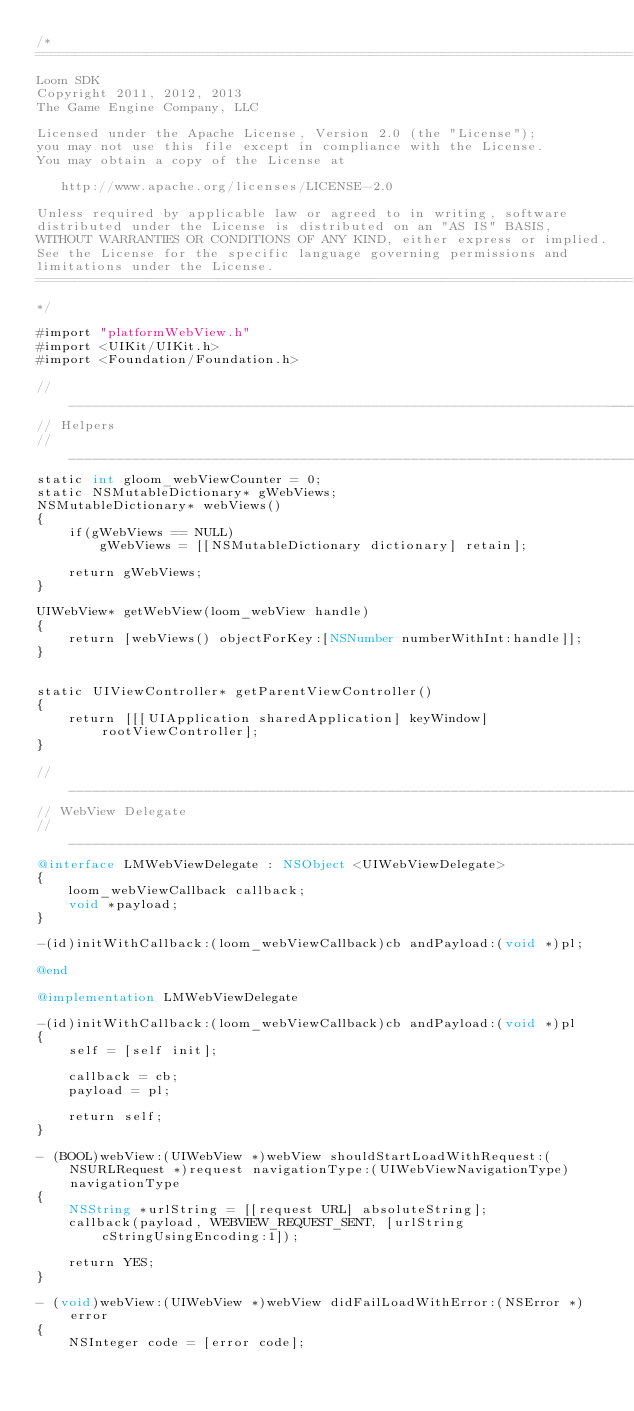<code> <loc_0><loc_0><loc_500><loc_500><_ObjectiveC_>/*
===========================================================================
Loom SDK
Copyright 2011, 2012, 2013 
The Game Engine Company, LLC

Licensed under the Apache License, Version 2.0 (the "License");
you may not use this file except in compliance with the License.
You may obtain a copy of the License at

   http://www.apache.org/licenses/LICENSE-2.0

Unless required by applicable law or agreed to in writing, software
distributed under the License is distributed on an "AS IS" BASIS,
WITHOUT WARRANTIES OR CONDITIONS OF ANY KIND, either express or implied.
See the License for the specific language governing permissions and
limitations under the License. 
===========================================================================
*/

#import "platformWebView.h"
#import <UIKit/UIKit.h>
#import <Foundation/Foundation.h>

//_________________________________________________________________________
// Helpers
//_________________________________________________________________________
static int gloom_webViewCounter = 0;
static NSMutableDictionary* gWebViews;
NSMutableDictionary* webViews()
{
    if(gWebViews == NULL)
        gWebViews = [[NSMutableDictionary dictionary] retain];
    
    return gWebViews;
}

UIWebView* getWebView(loom_webView handle)
{
    return [webViews() objectForKey:[NSNumber numberWithInt:handle]];
}


static UIViewController* getParentViewController()
{
    return [[[UIApplication sharedApplication] keyWindow] rootViewController];
}

//_________________________________________________________________________
// WebView Delegate
//_________________________________________________________________________
@interface LMWebViewDelegate : NSObject <UIWebViewDelegate>
{
    loom_webViewCallback callback;
    void *payload;
}

-(id)initWithCallback:(loom_webViewCallback)cb andPayload:(void *)pl;

@end

@implementation LMWebViewDelegate

-(id)initWithCallback:(loom_webViewCallback)cb andPayload:(void *)pl
{
    self = [self init];
    
    callback = cb;
    payload = pl;
    
    return self;
}

- (BOOL)webView:(UIWebView *)webView shouldStartLoadWithRequest:(NSURLRequest *)request navigationType:(UIWebViewNavigationType)navigationType
{
    NSString *urlString = [[request URL] absoluteString];
    callback(payload, WEBVIEW_REQUEST_SENT, [urlString cStringUsingEncoding:1]);

    return YES;
}

- (void)webView:(UIWebView *)webView didFailLoadWithError:(NSError *)error
{
    NSInteger code = [error code];</code> 